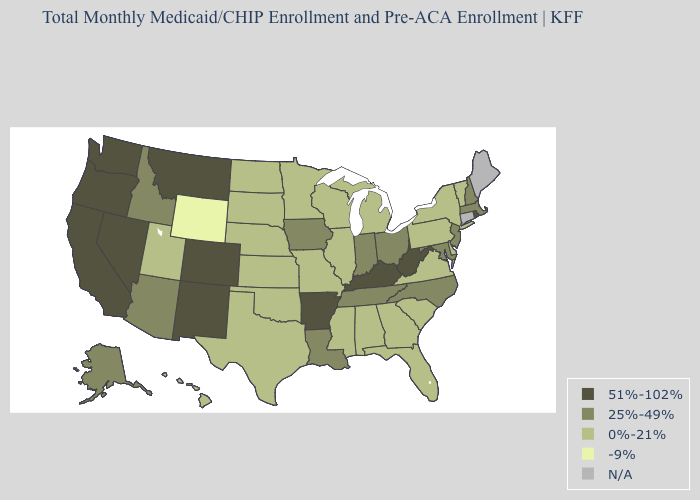Which states have the lowest value in the Northeast?
Short answer required. New York, Pennsylvania, Vermont. Does the first symbol in the legend represent the smallest category?
Answer briefly. No. What is the value of Iowa?
Write a very short answer. 25%-49%. What is the value of West Virginia?
Answer briefly. 51%-102%. Does the first symbol in the legend represent the smallest category?
Quick response, please. No. Name the states that have a value in the range 51%-102%?
Keep it brief. Arkansas, California, Colorado, Kentucky, Montana, Nevada, New Mexico, Oregon, Rhode Island, Washington, West Virginia. Name the states that have a value in the range 51%-102%?
Keep it brief. Arkansas, California, Colorado, Kentucky, Montana, Nevada, New Mexico, Oregon, Rhode Island, Washington, West Virginia. What is the highest value in the West ?
Short answer required. 51%-102%. Which states hav the highest value in the MidWest?
Give a very brief answer. Indiana, Iowa, Ohio. Name the states that have a value in the range 0%-21%?
Quick response, please. Alabama, Delaware, Florida, Georgia, Hawaii, Illinois, Kansas, Michigan, Minnesota, Mississippi, Missouri, Nebraska, New York, North Dakota, Oklahoma, Pennsylvania, South Carolina, South Dakota, Texas, Utah, Vermont, Virginia, Wisconsin. Which states hav the highest value in the Northeast?
Write a very short answer. Rhode Island. What is the highest value in the West ?
Keep it brief. 51%-102%. What is the lowest value in the Northeast?
Concise answer only. 0%-21%. Does the first symbol in the legend represent the smallest category?
Write a very short answer. No. 